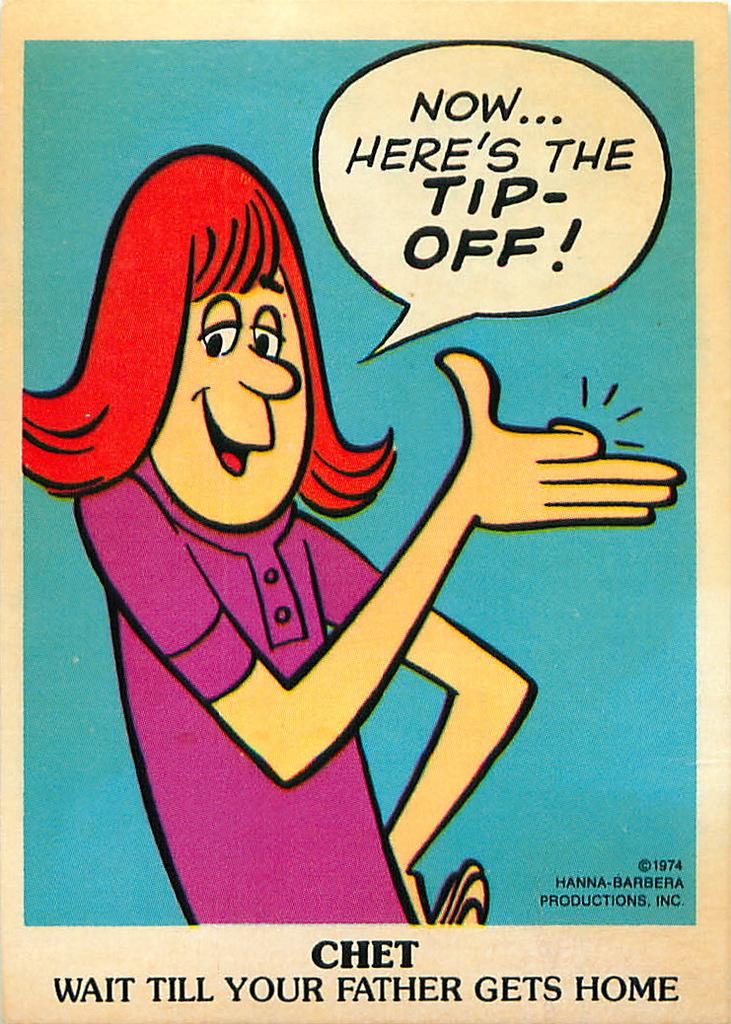<image>
Offer a succinct explanation of the picture presented. A woman cartoon figure that is saying now here's the tip-off. 